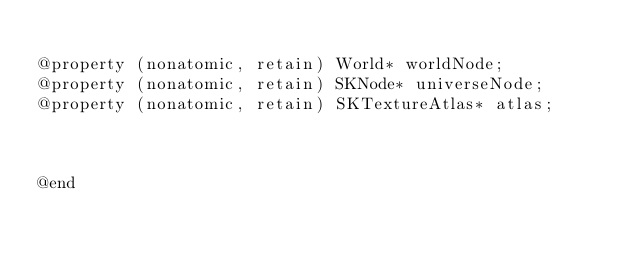Convert code to text. <code><loc_0><loc_0><loc_500><loc_500><_C_>
@property (nonatomic, retain) World* worldNode;
@property (nonatomic, retain) SKNode* universeNode;
@property (nonatomic, retain) SKTextureAtlas* atlas;



@end
</code> 